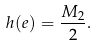<formula> <loc_0><loc_0><loc_500><loc_500>h ( e ) = \frac { M _ { 2 } } { 2 } .</formula> 